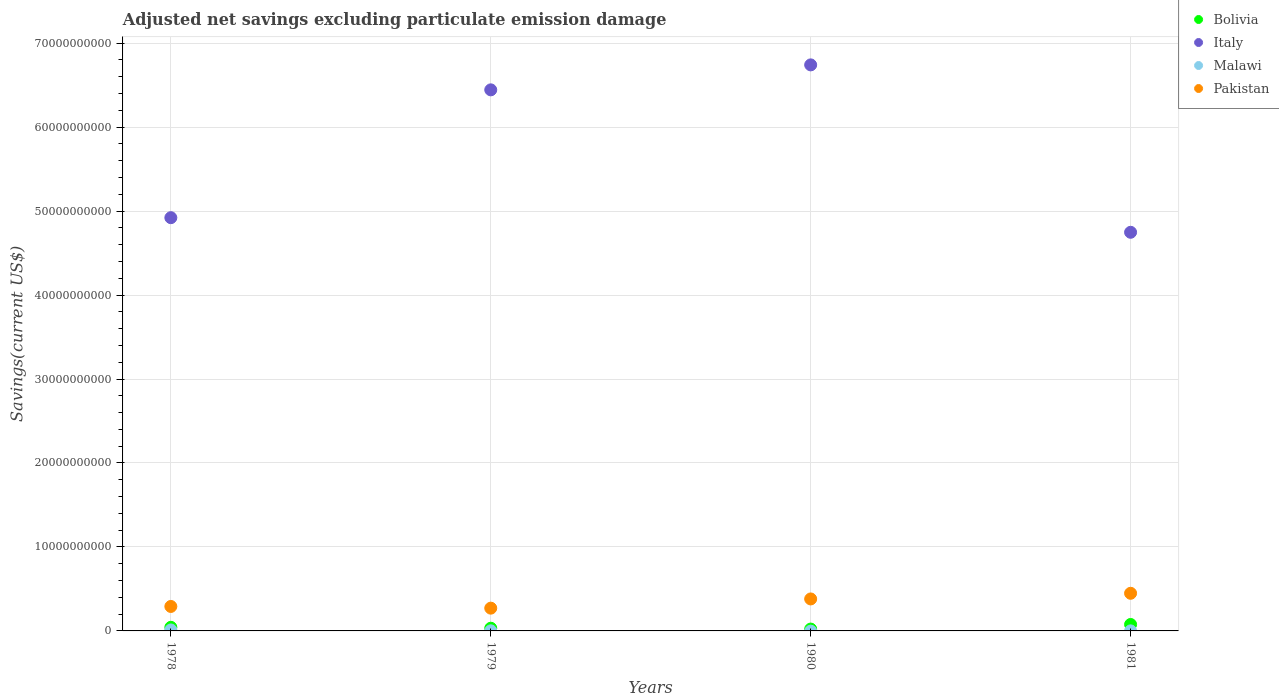How many different coloured dotlines are there?
Provide a succinct answer. 4. Is the number of dotlines equal to the number of legend labels?
Give a very brief answer. No. What is the adjusted net savings in Malawi in 1981?
Ensure brevity in your answer.  5.62e+06. Across all years, what is the maximum adjusted net savings in Pakistan?
Ensure brevity in your answer.  4.48e+09. In which year was the adjusted net savings in Bolivia maximum?
Your response must be concise. 1981. What is the total adjusted net savings in Pakistan in the graph?
Provide a short and direct response. 1.39e+1. What is the difference between the adjusted net savings in Pakistan in 1978 and that in 1979?
Give a very brief answer. 2.02e+08. What is the difference between the adjusted net savings in Italy in 1979 and the adjusted net savings in Malawi in 1978?
Your answer should be very brief. 6.43e+1. What is the average adjusted net savings in Malawi per year?
Keep it short and to the point. 3.31e+07. In the year 1978, what is the difference between the adjusted net savings in Pakistan and adjusted net savings in Bolivia?
Give a very brief answer. 2.48e+09. In how many years, is the adjusted net savings in Bolivia greater than 44000000000 US$?
Make the answer very short. 0. What is the ratio of the adjusted net savings in Bolivia in 1978 to that in 1979?
Your answer should be very brief. 1.33. What is the difference between the highest and the second highest adjusted net savings in Bolivia?
Offer a terse response. 3.39e+08. What is the difference between the highest and the lowest adjusted net savings in Malawi?
Give a very brief answer. 1.14e+08. Is it the case that in every year, the sum of the adjusted net savings in Malawi and adjusted net savings in Pakistan  is greater than the sum of adjusted net savings in Italy and adjusted net savings in Bolivia?
Offer a very short reply. Yes. Is the adjusted net savings in Italy strictly greater than the adjusted net savings in Malawi over the years?
Make the answer very short. Yes. How many dotlines are there?
Make the answer very short. 4. What is the difference between two consecutive major ticks on the Y-axis?
Offer a very short reply. 1.00e+1. Are the values on the major ticks of Y-axis written in scientific E-notation?
Offer a very short reply. No. Does the graph contain grids?
Ensure brevity in your answer.  Yes. Where does the legend appear in the graph?
Ensure brevity in your answer.  Top right. How are the legend labels stacked?
Offer a very short reply. Vertical. What is the title of the graph?
Make the answer very short. Adjusted net savings excluding particulate emission damage. Does "St. Vincent and the Grenadines" appear as one of the legend labels in the graph?
Offer a very short reply. No. What is the label or title of the Y-axis?
Provide a succinct answer. Savings(current US$). What is the Savings(current US$) of Bolivia in 1978?
Ensure brevity in your answer.  4.30e+08. What is the Savings(current US$) in Italy in 1978?
Give a very brief answer. 4.92e+1. What is the Savings(current US$) of Malawi in 1978?
Make the answer very short. 1.14e+08. What is the Savings(current US$) of Pakistan in 1978?
Offer a terse response. 2.91e+09. What is the Savings(current US$) of Bolivia in 1979?
Make the answer very short. 3.22e+08. What is the Savings(current US$) of Italy in 1979?
Offer a very short reply. 6.44e+1. What is the Savings(current US$) in Malawi in 1979?
Ensure brevity in your answer.  1.26e+07. What is the Savings(current US$) in Pakistan in 1979?
Provide a succinct answer. 2.71e+09. What is the Savings(current US$) in Bolivia in 1980?
Provide a short and direct response. 2.21e+08. What is the Savings(current US$) of Italy in 1980?
Provide a succinct answer. 6.74e+1. What is the Savings(current US$) of Pakistan in 1980?
Provide a short and direct response. 3.81e+09. What is the Savings(current US$) in Bolivia in 1981?
Your answer should be compact. 7.68e+08. What is the Savings(current US$) in Italy in 1981?
Offer a very short reply. 4.75e+1. What is the Savings(current US$) in Malawi in 1981?
Ensure brevity in your answer.  5.62e+06. What is the Savings(current US$) of Pakistan in 1981?
Provide a succinct answer. 4.48e+09. Across all years, what is the maximum Savings(current US$) in Bolivia?
Your answer should be compact. 7.68e+08. Across all years, what is the maximum Savings(current US$) of Italy?
Keep it short and to the point. 6.74e+1. Across all years, what is the maximum Savings(current US$) in Malawi?
Offer a very short reply. 1.14e+08. Across all years, what is the maximum Savings(current US$) of Pakistan?
Provide a succinct answer. 4.48e+09. Across all years, what is the minimum Savings(current US$) in Bolivia?
Provide a succinct answer. 2.21e+08. Across all years, what is the minimum Savings(current US$) of Italy?
Ensure brevity in your answer.  4.75e+1. Across all years, what is the minimum Savings(current US$) in Malawi?
Your response must be concise. 0. Across all years, what is the minimum Savings(current US$) of Pakistan?
Give a very brief answer. 2.71e+09. What is the total Savings(current US$) in Bolivia in the graph?
Give a very brief answer. 1.74e+09. What is the total Savings(current US$) in Italy in the graph?
Make the answer very short. 2.29e+11. What is the total Savings(current US$) of Malawi in the graph?
Give a very brief answer. 1.32e+08. What is the total Savings(current US$) of Pakistan in the graph?
Your response must be concise. 1.39e+1. What is the difference between the Savings(current US$) of Bolivia in 1978 and that in 1979?
Make the answer very short. 1.08e+08. What is the difference between the Savings(current US$) of Italy in 1978 and that in 1979?
Provide a succinct answer. -1.52e+1. What is the difference between the Savings(current US$) of Malawi in 1978 and that in 1979?
Offer a terse response. 1.02e+08. What is the difference between the Savings(current US$) of Pakistan in 1978 and that in 1979?
Your answer should be very brief. 2.02e+08. What is the difference between the Savings(current US$) of Bolivia in 1978 and that in 1980?
Offer a terse response. 2.09e+08. What is the difference between the Savings(current US$) of Italy in 1978 and that in 1980?
Provide a short and direct response. -1.82e+1. What is the difference between the Savings(current US$) in Pakistan in 1978 and that in 1980?
Offer a very short reply. -8.95e+08. What is the difference between the Savings(current US$) of Bolivia in 1978 and that in 1981?
Give a very brief answer. -3.39e+08. What is the difference between the Savings(current US$) of Italy in 1978 and that in 1981?
Ensure brevity in your answer.  1.74e+09. What is the difference between the Savings(current US$) of Malawi in 1978 and that in 1981?
Your answer should be very brief. 1.09e+08. What is the difference between the Savings(current US$) in Pakistan in 1978 and that in 1981?
Offer a very short reply. -1.57e+09. What is the difference between the Savings(current US$) in Bolivia in 1979 and that in 1980?
Give a very brief answer. 1.01e+08. What is the difference between the Savings(current US$) in Italy in 1979 and that in 1980?
Provide a short and direct response. -2.97e+09. What is the difference between the Savings(current US$) of Pakistan in 1979 and that in 1980?
Offer a terse response. -1.10e+09. What is the difference between the Savings(current US$) of Bolivia in 1979 and that in 1981?
Make the answer very short. -4.47e+08. What is the difference between the Savings(current US$) in Italy in 1979 and that in 1981?
Ensure brevity in your answer.  1.70e+1. What is the difference between the Savings(current US$) of Malawi in 1979 and that in 1981?
Ensure brevity in your answer.  7.02e+06. What is the difference between the Savings(current US$) of Pakistan in 1979 and that in 1981?
Provide a short and direct response. -1.77e+09. What is the difference between the Savings(current US$) of Bolivia in 1980 and that in 1981?
Provide a succinct answer. -5.47e+08. What is the difference between the Savings(current US$) of Italy in 1980 and that in 1981?
Provide a short and direct response. 1.99e+1. What is the difference between the Savings(current US$) of Pakistan in 1980 and that in 1981?
Provide a succinct answer. -6.74e+08. What is the difference between the Savings(current US$) in Bolivia in 1978 and the Savings(current US$) in Italy in 1979?
Make the answer very short. -6.40e+1. What is the difference between the Savings(current US$) of Bolivia in 1978 and the Savings(current US$) of Malawi in 1979?
Your answer should be compact. 4.17e+08. What is the difference between the Savings(current US$) of Bolivia in 1978 and the Savings(current US$) of Pakistan in 1979?
Make the answer very short. -2.28e+09. What is the difference between the Savings(current US$) of Italy in 1978 and the Savings(current US$) of Malawi in 1979?
Your answer should be very brief. 4.92e+1. What is the difference between the Savings(current US$) of Italy in 1978 and the Savings(current US$) of Pakistan in 1979?
Offer a terse response. 4.65e+1. What is the difference between the Savings(current US$) in Malawi in 1978 and the Savings(current US$) in Pakistan in 1979?
Your answer should be compact. -2.60e+09. What is the difference between the Savings(current US$) in Bolivia in 1978 and the Savings(current US$) in Italy in 1980?
Your answer should be very brief. -6.70e+1. What is the difference between the Savings(current US$) of Bolivia in 1978 and the Savings(current US$) of Pakistan in 1980?
Offer a terse response. -3.38e+09. What is the difference between the Savings(current US$) of Italy in 1978 and the Savings(current US$) of Pakistan in 1980?
Your response must be concise. 4.54e+1. What is the difference between the Savings(current US$) in Malawi in 1978 and the Savings(current US$) in Pakistan in 1980?
Provide a short and direct response. -3.69e+09. What is the difference between the Savings(current US$) of Bolivia in 1978 and the Savings(current US$) of Italy in 1981?
Make the answer very short. -4.70e+1. What is the difference between the Savings(current US$) of Bolivia in 1978 and the Savings(current US$) of Malawi in 1981?
Your answer should be very brief. 4.24e+08. What is the difference between the Savings(current US$) of Bolivia in 1978 and the Savings(current US$) of Pakistan in 1981?
Offer a terse response. -4.05e+09. What is the difference between the Savings(current US$) of Italy in 1978 and the Savings(current US$) of Malawi in 1981?
Give a very brief answer. 4.92e+1. What is the difference between the Savings(current US$) in Italy in 1978 and the Savings(current US$) in Pakistan in 1981?
Provide a succinct answer. 4.47e+1. What is the difference between the Savings(current US$) in Malawi in 1978 and the Savings(current US$) in Pakistan in 1981?
Your response must be concise. -4.37e+09. What is the difference between the Savings(current US$) in Bolivia in 1979 and the Savings(current US$) in Italy in 1980?
Your answer should be very brief. -6.71e+1. What is the difference between the Savings(current US$) in Bolivia in 1979 and the Savings(current US$) in Pakistan in 1980?
Your answer should be compact. -3.49e+09. What is the difference between the Savings(current US$) of Italy in 1979 and the Savings(current US$) of Pakistan in 1980?
Make the answer very short. 6.06e+1. What is the difference between the Savings(current US$) in Malawi in 1979 and the Savings(current US$) in Pakistan in 1980?
Your answer should be compact. -3.80e+09. What is the difference between the Savings(current US$) in Bolivia in 1979 and the Savings(current US$) in Italy in 1981?
Offer a very short reply. -4.72e+1. What is the difference between the Savings(current US$) of Bolivia in 1979 and the Savings(current US$) of Malawi in 1981?
Provide a succinct answer. 3.16e+08. What is the difference between the Savings(current US$) in Bolivia in 1979 and the Savings(current US$) in Pakistan in 1981?
Provide a succinct answer. -4.16e+09. What is the difference between the Savings(current US$) in Italy in 1979 and the Savings(current US$) in Malawi in 1981?
Give a very brief answer. 6.44e+1. What is the difference between the Savings(current US$) in Italy in 1979 and the Savings(current US$) in Pakistan in 1981?
Offer a terse response. 6.00e+1. What is the difference between the Savings(current US$) in Malawi in 1979 and the Savings(current US$) in Pakistan in 1981?
Your response must be concise. -4.47e+09. What is the difference between the Savings(current US$) in Bolivia in 1980 and the Savings(current US$) in Italy in 1981?
Your response must be concise. -4.73e+1. What is the difference between the Savings(current US$) in Bolivia in 1980 and the Savings(current US$) in Malawi in 1981?
Make the answer very short. 2.15e+08. What is the difference between the Savings(current US$) of Bolivia in 1980 and the Savings(current US$) of Pakistan in 1981?
Offer a terse response. -4.26e+09. What is the difference between the Savings(current US$) of Italy in 1980 and the Savings(current US$) of Malawi in 1981?
Give a very brief answer. 6.74e+1. What is the difference between the Savings(current US$) of Italy in 1980 and the Savings(current US$) of Pakistan in 1981?
Provide a succinct answer. 6.29e+1. What is the average Savings(current US$) of Bolivia per year?
Make the answer very short. 4.35e+08. What is the average Savings(current US$) in Italy per year?
Offer a terse response. 5.71e+1. What is the average Savings(current US$) in Malawi per year?
Your response must be concise. 3.31e+07. What is the average Savings(current US$) of Pakistan per year?
Give a very brief answer. 3.48e+09. In the year 1978, what is the difference between the Savings(current US$) in Bolivia and Savings(current US$) in Italy?
Your answer should be very brief. -4.88e+1. In the year 1978, what is the difference between the Savings(current US$) of Bolivia and Savings(current US$) of Malawi?
Your response must be concise. 3.15e+08. In the year 1978, what is the difference between the Savings(current US$) in Bolivia and Savings(current US$) in Pakistan?
Your response must be concise. -2.48e+09. In the year 1978, what is the difference between the Savings(current US$) of Italy and Savings(current US$) of Malawi?
Ensure brevity in your answer.  4.91e+1. In the year 1978, what is the difference between the Savings(current US$) of Italy and Savings(current US$) of Pakistan?
Provide a succinct answer. 4.63e+1. In the year 1978, what is the difference between the Savings(current US$) in Malawi and Savings(current US$) in Pakistan?
Offer a very short reply. -2.80e+09. In the year 1979, what is the difference between the Savings(current US$) in Bolivia and Savings(current US$) in Italy?
Give a very brief answer. -6.41e+1. In the year 1979, what is the difference between the Savings(current US$) in Bolivia and Savings(current US$) in Malawi?
Your answer should be very brief. 3.09e+08. In the year 1979, what is the difference between the Savings(current US$) in Bolivia and Savings(current US$) in Pakistan?
Offer a terse response. -2.39e+09. In the year 1979, what is the difference between the Savings(current US$) of Italy and Savings(current US$) of Malawi?
Your answer should be very brief. 6.44e+1. In the year 1979, what is the difference between the Savings(current US$) of Italy and Savings(current US$) of Pakistan?
Keep it short and to the point. 6.17e+1. In the year 1979, what is the difference between the Savings(current US$) in Malawi and Savings(current US$) in Pakistan?
Provide a short and direct response. -2.70e+09. In the year 1980, what is the difference between the Savings(current US$) of Bolivia and Savings(current US$) of Italy?
Keep it short and to the point. -6.72e+1. In the year 1980, what is the difference between the Savings(current US$) of Bolivia and Savings(current US$) of Pakistan?
Your answer should be very brief. -3.59e+09. In the year 1980, what is the difference between the Savings(current US$) of Italy and Savings(current US$) of Pakistan?
Give a very brief answer. 6.36e+1. In the year 1981, what is the difference between the Savings(current US$) in Bolivia and Savings(current US$) in Italy?
Offer a terse response. -4.67e+1. In the year 1981, what is the difference between the Savings(current US$) of Bolivia and Savings(current US$) of Malawi?
Offer a very short reply. 7.63e+08. In the year 1981, what is the difference between the Savings(current US$) in Bolivia and Savings(current US$) in Pakistan?
Keep it short and to the point. -3.71e+09. In the year 1981, what is the difference between the Savings(current US$) of Italy and Savings(current US$) of Malawi?
Your answer should be compact. 4.75e+1. In the year 1981, what is the difference between the Savings(current US$) in Italy and Savings(current US$) in Pakistan?
Make the answer very short. 4.30e+1. In the year 1981, what is the difference between the Savings(current US$) of Malawi and Savings(current US$) of Pakistan?
Offer a terse response. -4.48e+09. What is the ratio of the Savings(current US$) of Bolivia in 1978 to that in 1979?
Ensure brevity in your answer.  1.33. What is the ratio of the Savings(current US$) of Italy in 1978 to that in 1979?
Offer a terse response. 0.76. What is the ratio of the Savings(current US$) in Malawi in 1978 to that in 1979?
Offer a very short reply. 9.04. What is the ratio of the Savings(current US$) of Pakistan in 1978 to that in 1979?
Provide a short and direct response. 1.07. What is the ratio of the Savings(current US$) in Bolivia in 1978 to that in 1980?
Give a very brief answer. 1.94. What is the ratio of the Savings(current US$) of Italy in 1978 to that in 1980?
Your response must be concise. 0.73. What is the ratio of the Savings(current US$) in Pakistan in 1978 to that in 1980?
Provide a succinct answer. 0.77. What is the ratio of the Savings(current US$) of Bolivia in 1978 to that in 1981?
Provide a short and direct response. 0.56. What is the ratio of the Savings(current US$) in Italy in 1978 to that in 1981?
Offer a terse response. 1.04. What is the ratio of the Savings(current US$) in Malawi in 1978 to that in 1981?
Provide a short and direct response. 20.34. What is the ratio of the Savings(current US$) of Pakistan in 1978 to that in 1981?
Your answer should be compact. 0.65. What is the ratio of the Savings(current US$) in Bolivia in 1979 to that in 1980?
Ensure brevity in your answer.  1.46. What is the ratio of the Savings(current US$) of Italy in 1979 to that in 1980?
Provide a succinct answer. 0.96. What is the ratio of the Savings(current US$) in Pakistan in 1979 to that in 1980?
Provide a succinct answer. 0.71. What is the ratio of the Savings(current US$) of Bolivia in 1979 to that in 1981?
Provide a short and direct response. 0.42. What is the ratio of the Savings(current US$) of Italy in 1979 to that in 1981?
Make the answer very short. 1.36. What is the ratio of the Savings(current US$) of Malawi in 1979 to that in 1981?
Your answer should be compact. 2.25. What is the ratio of the Savings(current US$) in Pakistan in 1979 to that in 1981?
Keep it short and to the point. 0.6. What is the ratio of the Savings(current US$) of Bolivia in 1980 to that in 1981?
Ensure brevity in your answer.  0.29. What is the ratio of the Savings(current US$) in Italy in 1980 to that in 1981?
Give a very brief answer. 1.42. What is the ratio of the Savings(current US$) of Pakistan in 1980 to that in 1981?
Give a very brief answer. 0.85. What is the difference between the highest and the second highest Savings(current US$) in Bolivia?
Offer a very short reply. 3.39e+08. What is the difference between the highest and the second highest Savings(current US$) in Italy?
Your answer should be compact. 2.97e+09. What is the difference between the highest and the second highest Savings(current US$) of Malawi?
Provide a succinct answer. 1.02e+08. What is the difference between the highest and the second highest Savings(current US$) of Pakistan?
Provide a succinct answer. 6.74e+08. What is the difference between the highest and the lowest Savings(current US$) of Bolivia?
Give a very brief answer. 5.47e+08. What is the difference between the highest and the lowest Savings(current US$) in Italy?
Your answer should be very brief. 1.99e+1. What is the difference between the highest and the lowest Savings(current US$) of Malawi?
Ensure brevity in your answer.  1.14e+08. What is the difference between the highest and the lowest Savings(current US$) of Pakistan?
Provide a succinct answer. 1.77e+09. 